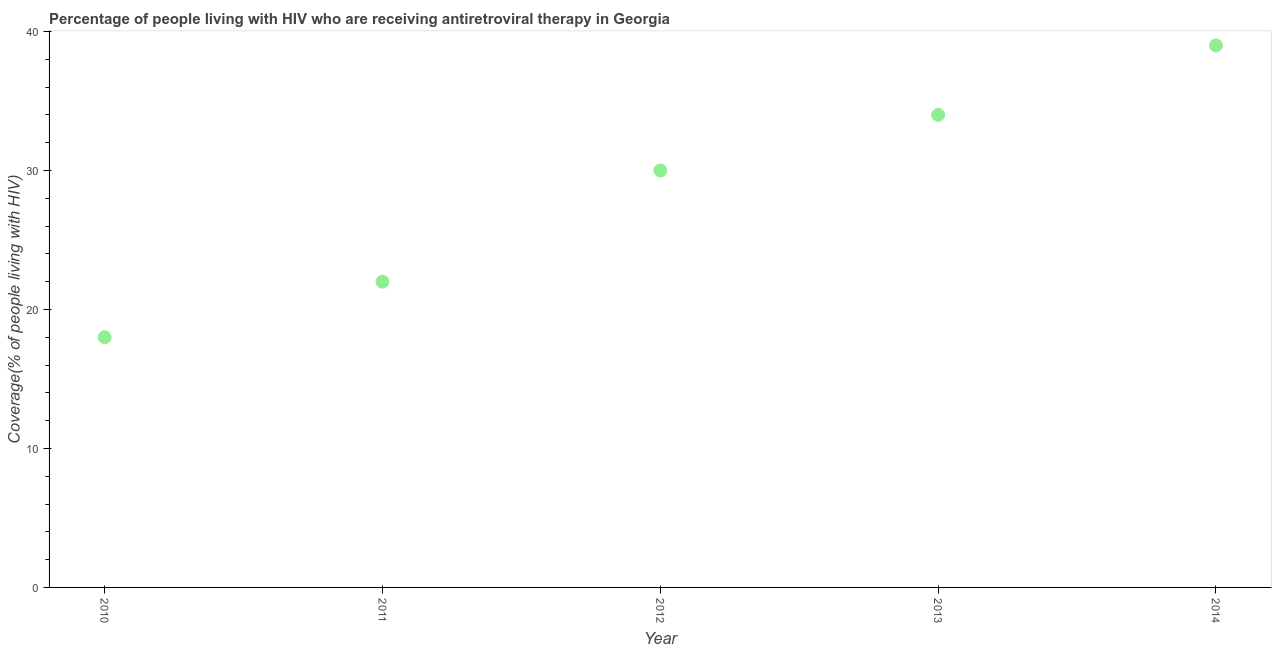What is the antiretroviral therapy coverage in 2011?
Make the answer very short. 22. Across all years, what is the maximum antiretroviral therapy coverage?
Ensure brevity in your answer.  39. Across all years, what is the minimum antiretroviral therapy coverage?
Your response must be concise. 18. In which year was the antiretroviral therapy coverage maximum?
Keep it short and to the point. 2014. What is the sum of the antiretroviral therapy coverage?
Give a very brief answer. 143. What is the difference between the antiretroviral therapy coverage in 2013 and 2014?
Make the answer very short. -5. What is the average antiretroviral therapy coverage per year?
Your response must be concise. 28.6. What is the median antiretroviral therapy coverage?
Your response must be concise. 30. What is the ratio of the antiretroviral therapy coverage in 2010 to that in 2011?
Offer a terse response. 0.82. Is the antiretroviral therapy coverage in 2010 less than that in 2012?
Keep it short and to the point. Yes. What is the difference between the highest and the second highest antiretroviral therapy coverage?
Ensure brevity in your answer.  5. Is the sum of the antiretroviral therapy coverage in 2010 and 2014 greater than the maximum antiretroviral therapy coverage across all years?
Keep it short and to the point. Yes. What is the difference between the highest and the lowest antiretroviral therapy coverage?
Make the answer very short. 21. Does the antiretroviral therapy coverage monotonically increase over the years?
Give a very brief answer. Yes. How many dotlines are there?
Provide a short and direct response. 1. How many years are there in the graph?
Offer a terse response. 5. What is the difference between two consecutive major ticks on the Y-axis?
Your answer should be compact. 10. Are the values on the major ticks of Y-axis written in scientific E-notation?
Your answer should be very brief. No. What is the title of the graph?
Provide a short and direct response. Percentage of people living with HIV who are receiving antiretroviral therapy in Georgia. What is the label or title of the Y-axis?
Give a very brief answer. Coverage(% of people living with HIV). What is the Coverage(% of people living with HIV) in 2010?
Your answer should be compact. 18. What is the Coverage(% of people living with HIV) in 2011?
Your answer should be compact. 22. What is the difference between the Coverage(% of people living with HIV) in 2011 and 2012?
Offer a terse response. -8. What is the difference between the Coverage(% of people living with HIV) in 2011 and 2014?
Your answer should be compact. -17. What is the difference between the Coverage(% of people living with HIV) in 2012 and 2013?
Ensure brevity in your answer.  -4. What is the difference between the Coverage(% of people living with HIV) in 2012 and 2014?
Your answer should be very brief. -9. What is the difference between the Coverage(% of people living with HIV) in 2013 and 2014?
Ensure brevity in your answer.  -5. What is the ratio of the Coverage(% of people living with HIV) in 2010 to that in 2011?
Your answer should be very brief. 0.82. What is the ratio of the Coverage(% of people living with HIV) in 2010 to that in 2012?
Give a very brief answer. 0.6. What is the ratio of the Coverage(% of people living with HIV) in 2010 to that in 2013?
Your answer should be very brief. 0.53. What is the ratio of the Coverage(% of people living with HIV) in 2010 to that in 2014?
Provide a succinct answer. 0.46. What is the ratio of the Coverage(% of people living with HIV) in 2011 to that in 2012?
Offer a terse response. 0.73. What is the ratio of the Coverage(% of people living with HIV) in 2011 to that in 2013?
Your answer should be compact. 0.65. What is the ratio of the Coverage(% of people living with HIV) in 2011 to that in 2014?
Ensure brevity in your answer.  0.56. What is the ratio of the Coverage(% of people living with HIV) in 2012 to that in 2013?
Keep it short and to the point. 0.88. What is the ratio of the Coverage(% of people living with HIV) in 2012 to that in 2014?
Offer a very short reply. 0.77. What is the ratio of the Coverage(% of people living with HIV) in 2013 to that in 2014?
Give a very brief answer. 0.87. 